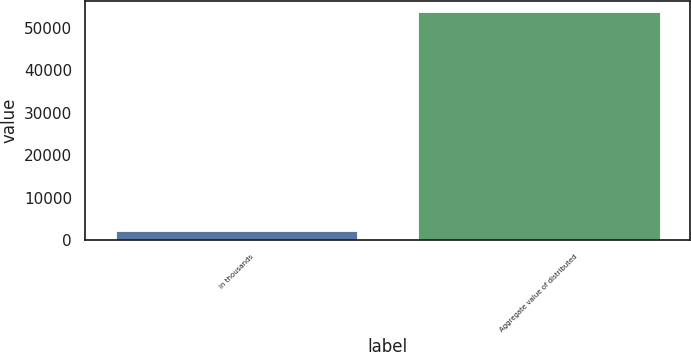Convert chart. <chart><loc_0><loc_0><loc_500><loc_500><bar_chart><fcel>in thousands<fcel>Aggregate value of distributed<nl><fcel>2018<fcel>53721<nl></chart> 